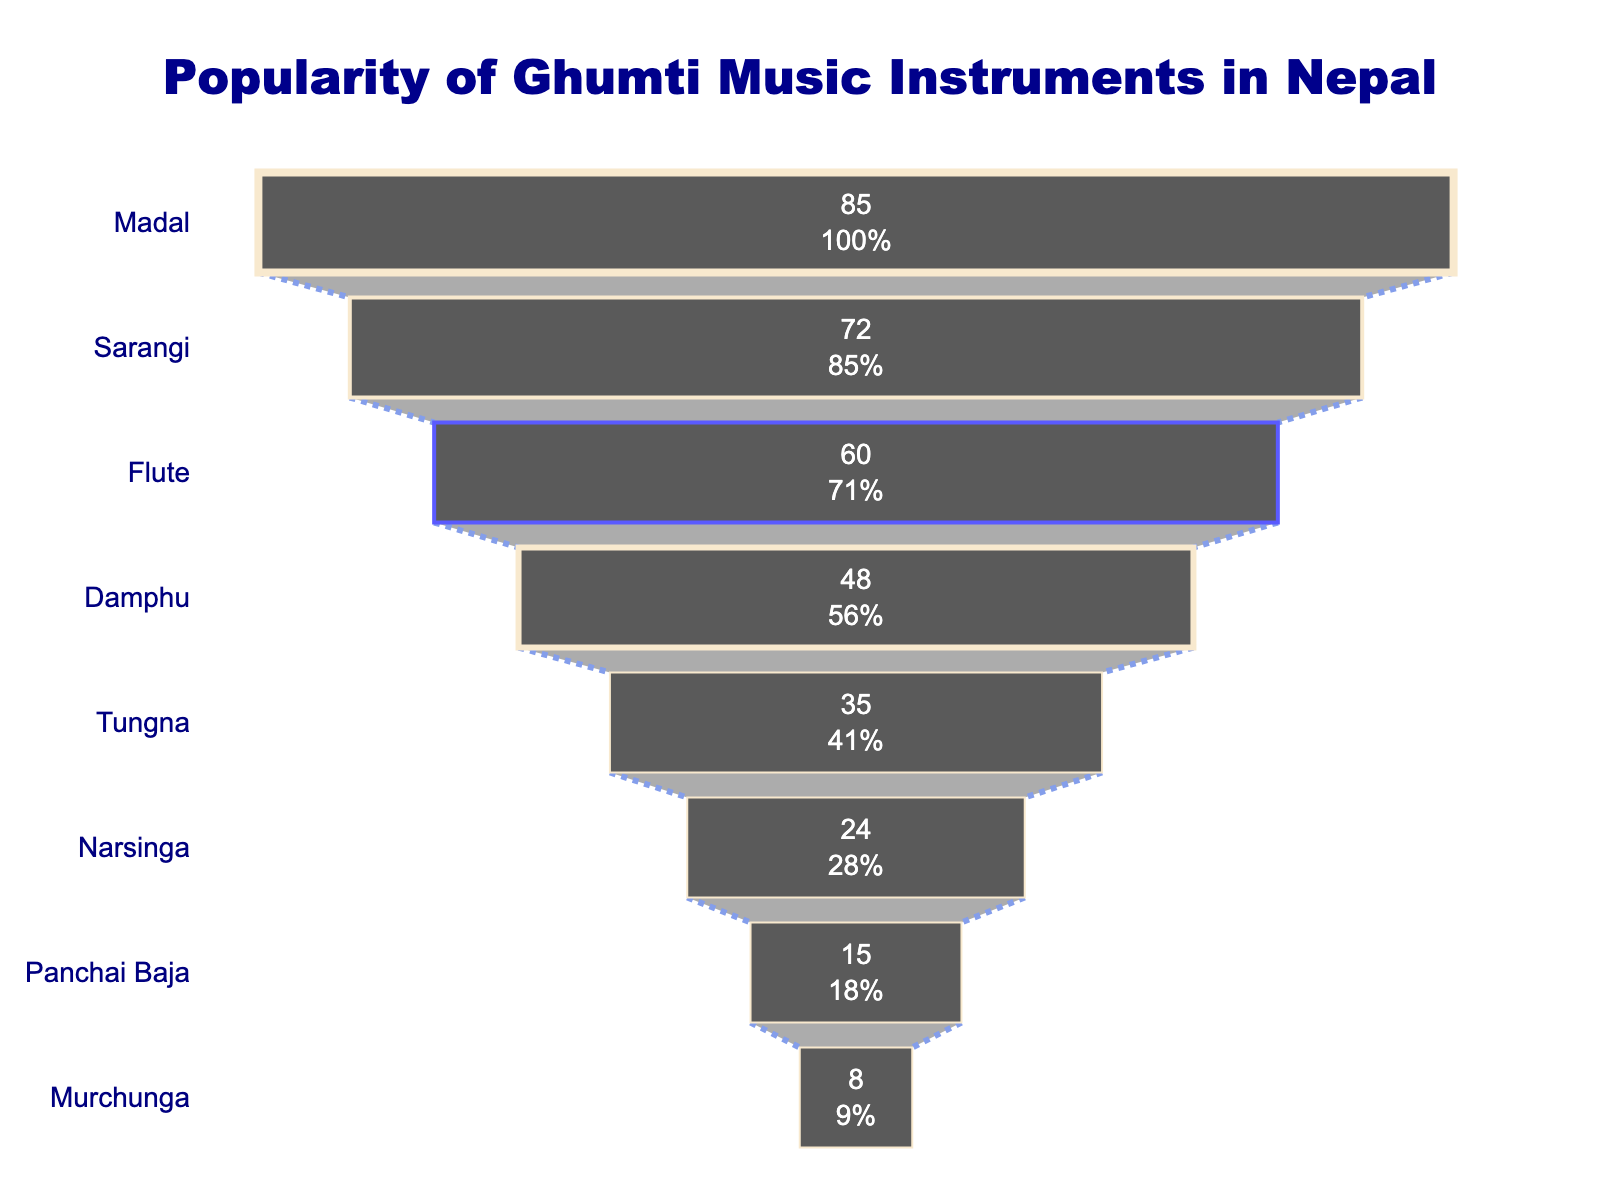Which instrument is the most popular among Nepali musicians? The instrument with the highest value in the funnel chart is the most popular. The chart shows "Madal" with the highest value of 85.
Answer: Madal How many more musicians play the Sarangi compared to the Narsinga? Identify the popularity of Sarangi and Narsinga from the chart. Sarangi has a popularity of 72, while Narsinga has a popularity of 24. Subtract the smaller number from the larger one, 72 - 24 = 48.
Answer: 48 What percentage of the initial value does the Flute represent? Locate the Flute on the chart, which has a value of 60. Determine the initial value, which is 85 (the value of Madal). Calculate the percentage: (60 / 85) * 100 ≈ 70.6%.
Answer: 70.6% Which instrument shows a steep drop from the Madal in popularity? A steep drop indicates a significant decrease in popularity value from one instrument to the next. The next level after Madal is Sarangi with a popularity of 72, which isn't very steep. The significant drop is from Sarangi (72) to Flute (60), thus Sarangi shows a steep drop compared to Madal.
Answer: Sarangi What is the least common Ghumti music instrument among Nepali musicians? Identify the instrument with the lowest value in the funnel chart, which is "Murchunga" with a value of 8.
Answer: Murchunga If 30 more musicians started playing Tungna, how would its popularity compare to the Damphu? Tungna has a current popularity of 35. Adding 30 more musicians gives 35 + 30 = 65. Damphu has a popularity of 48, so Tungna would have a higher popularity than Damphu with 65.
Answer: 65, higher Calculate the average popularity of the top three instruments. Identify the values of the top three instruments: Madal (85), Sarangi (72), and Flute (60). Sum these values: 85 + 72 + 60 = 217. Divide by 3 to find the average: 217 / 3 ≈ 72.3.
Answer: 72.3 Which instrument has a popularity closest to the median value of all instruments? List the popularity values in ascending order: 8, 15, 24, 35, 48, 60, 72, 85. The median is the average of the 4th and 5th values: (35 + 48) / 2 = 41.5. The instrument closest to 41.5 is Tungna with a popularity of 35.
Answer: Tungna By what percentage does the popularity of Damphu exceed that of Panchai Baja? Damphu has a popularity of 48, and Panchai Baja has a popularity of 15. Calculate the percentage increase: ((48 - 15) / 15) * 100 ≈ 220%.
Answer: 220% 